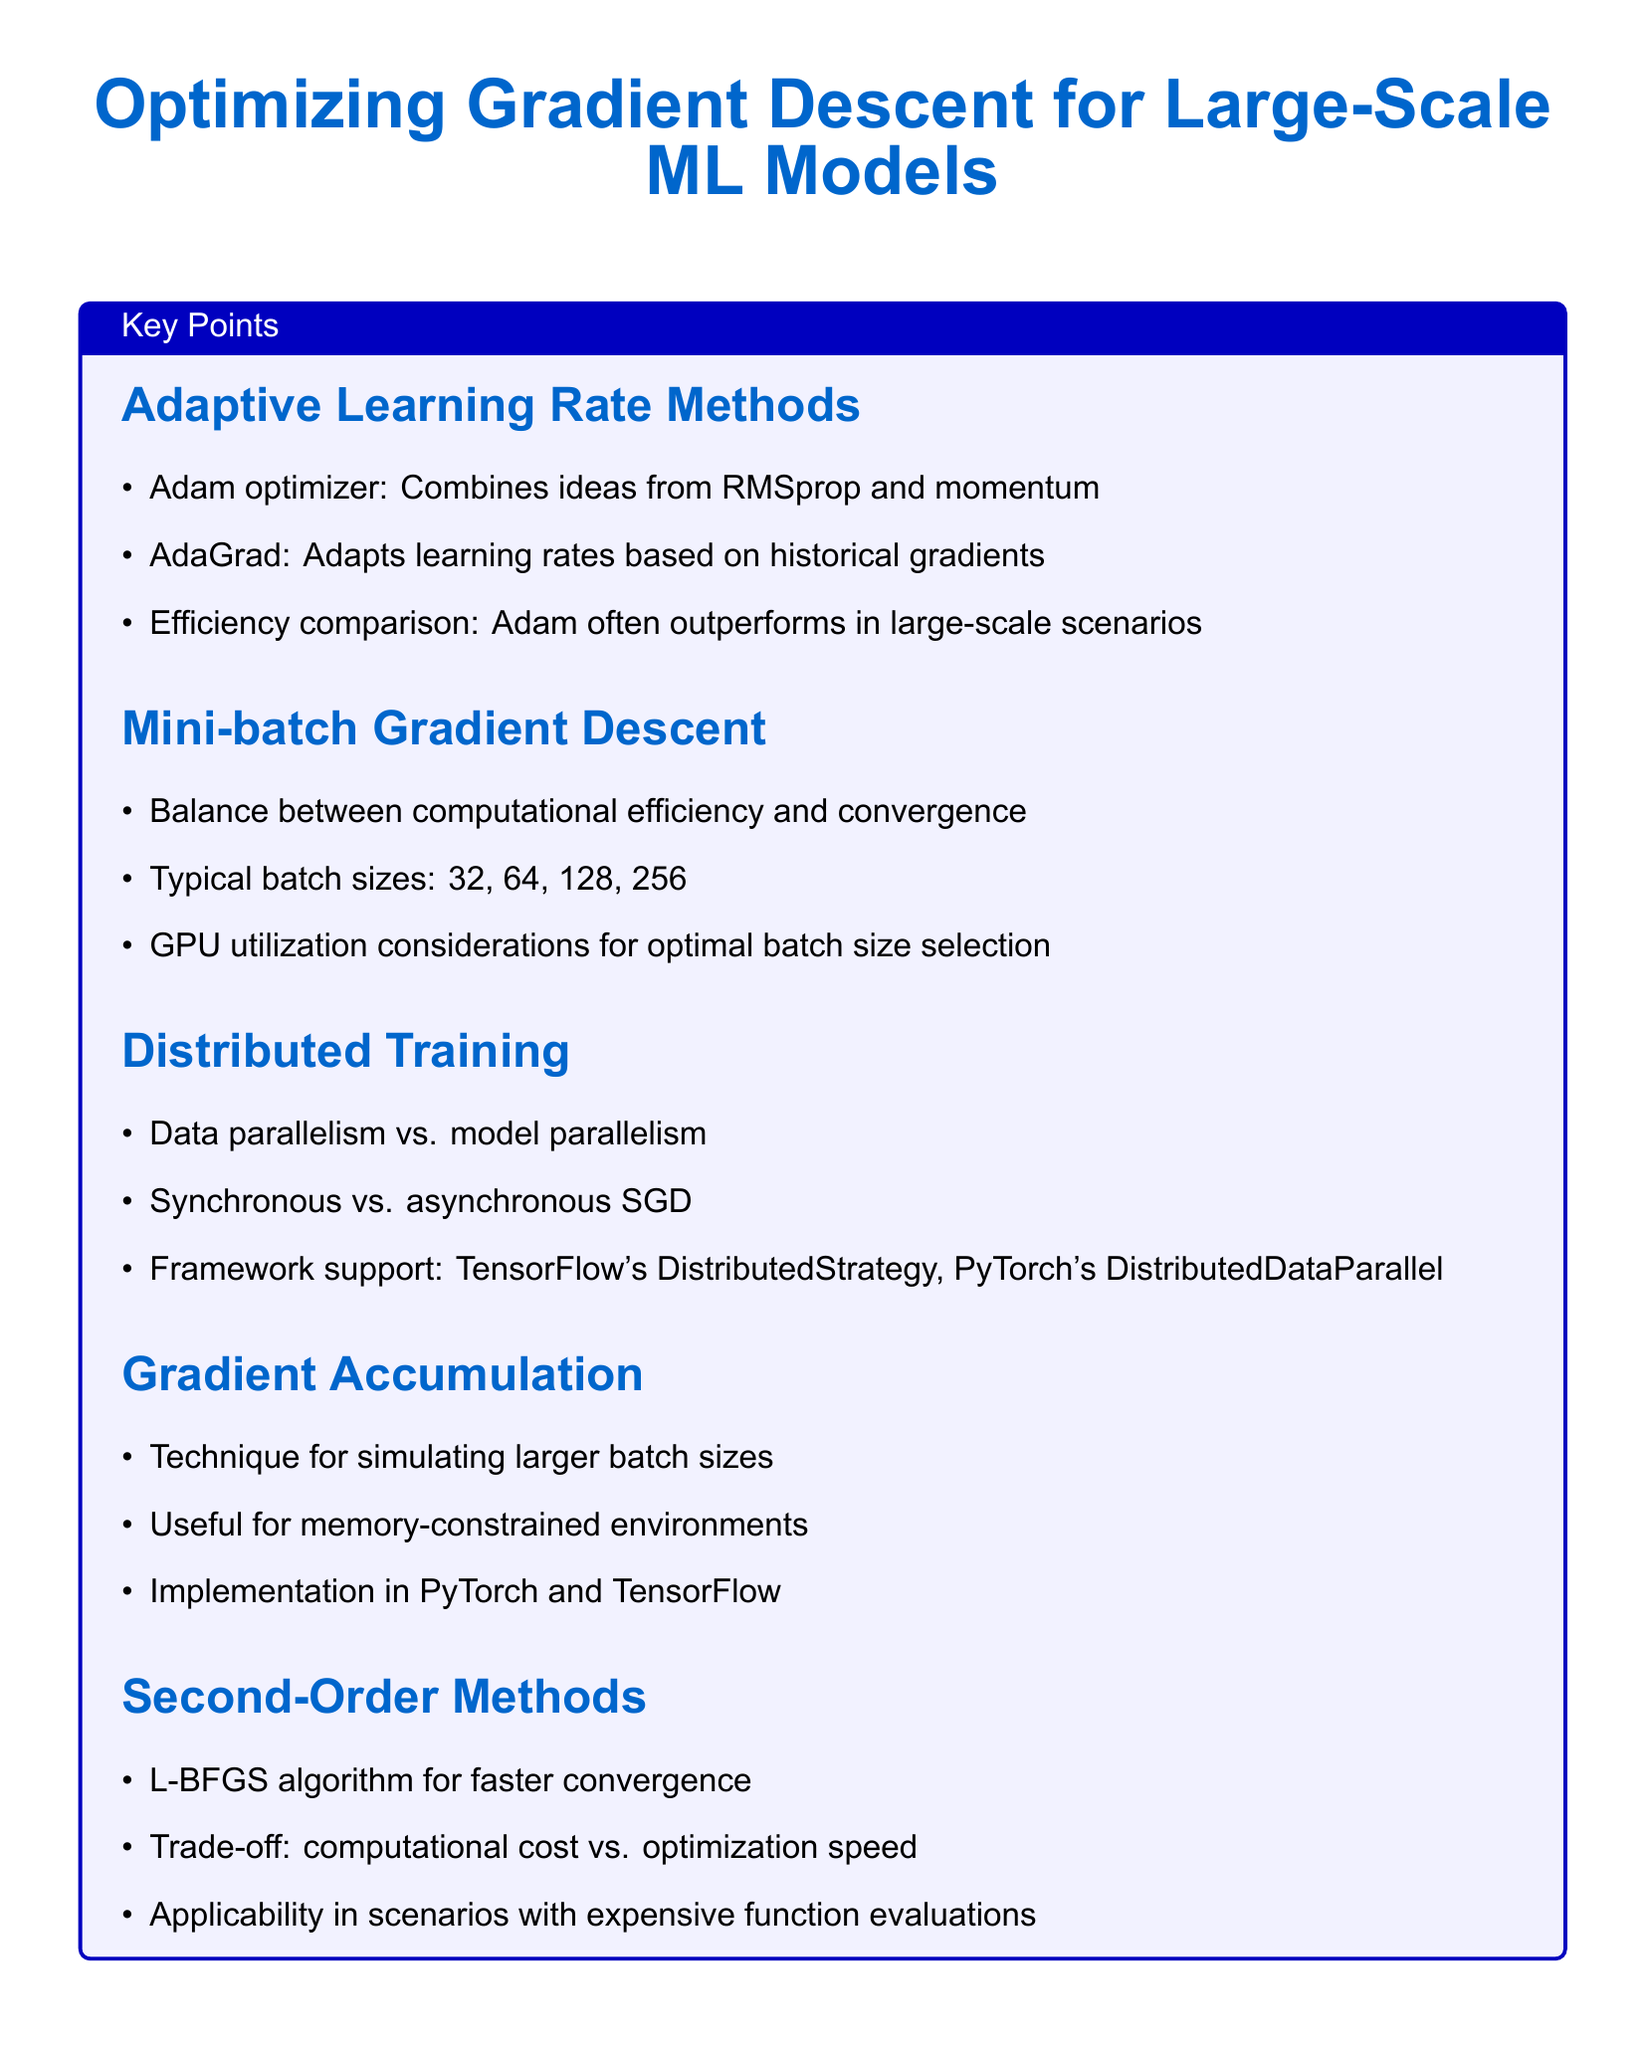What are the three adaptive learning rate methods mentioned? The document lists Adam, AdaGrad, and RMSprop as adaptive learning rate methods.
Answer: Adam, AdaGrad, RMSprop What are the typical mini-batch sizes? Typical batch sizes according to the document are stated, which are 32, 64, 128, and 256.
Answer: 32, 64, 128, 256 What is the main purpose of gradient accumulation? The document describes gradient accumulation as a technique to simulate larger batch sizes.
Answer: Simulating larger batch sizes Which optimizer is mentioned for faster convergence? The document specifically mentions the L-BFGS algorithm for faster convergence.
Answer: L-BFGS What is one of the practical tips for improving efficiency in code? The document suggests profiling code as a practical tip for identifying bottlenecks.
Answer: Profile code What framework supports distributed training? The document discusses TensorFlow's DistributedStrategy and PyTorch's DistributedDataParallel as frameworks supporting distributed training.
Answer: TensorFlow, PyTorch How does Adam compare in terms of efficiency? The document states that Adam often outperforms other methods in large-scale scenarios regarding efficiency.
Answer: Often outperforms What does mixed-precision training help with? The document highlights mixed-precision training as a method for faster computation on compatible hardware.
Answer: Faster computation 